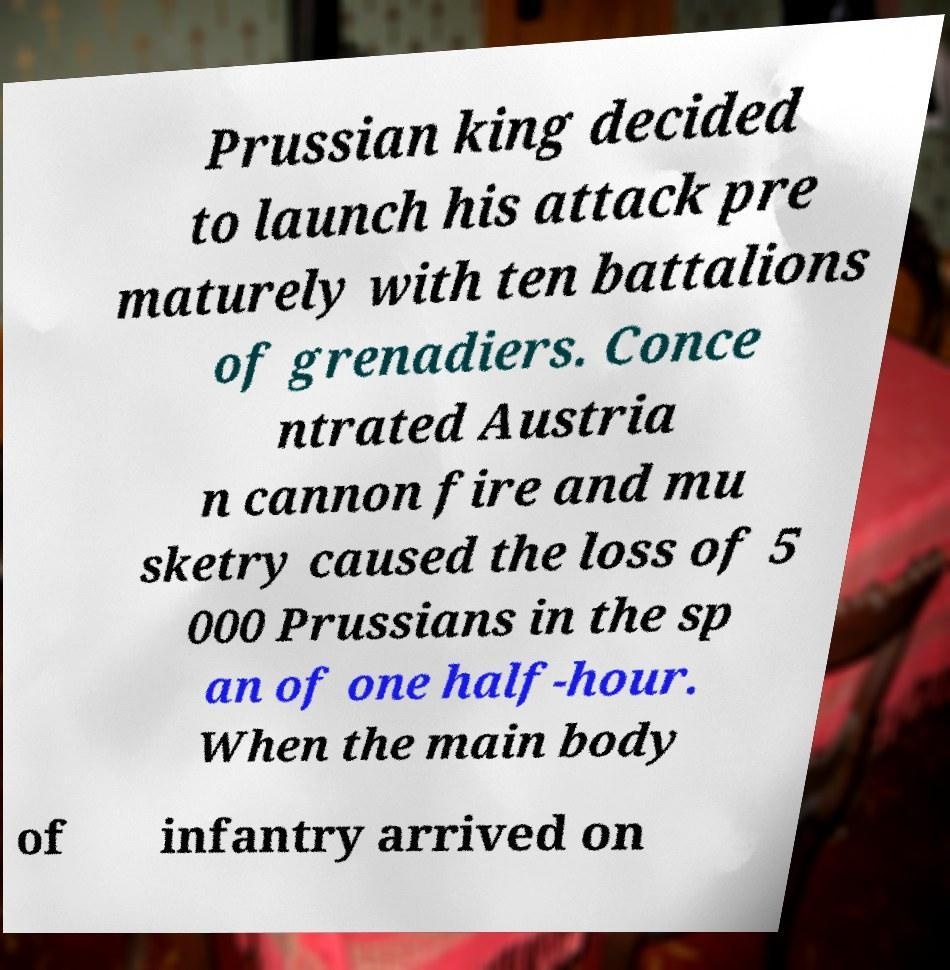For documentation purposes, I need the text within this image transcribed. Could you provide that? Prussian king decided to launch his attack pre maturely with ten battalions of grenadiers. Conce ntrated Austria n cannon fire and mu sketry caused the loss of 5 000 Prussians in the sp an of one half-hour. When the main body of infantry arrived on 